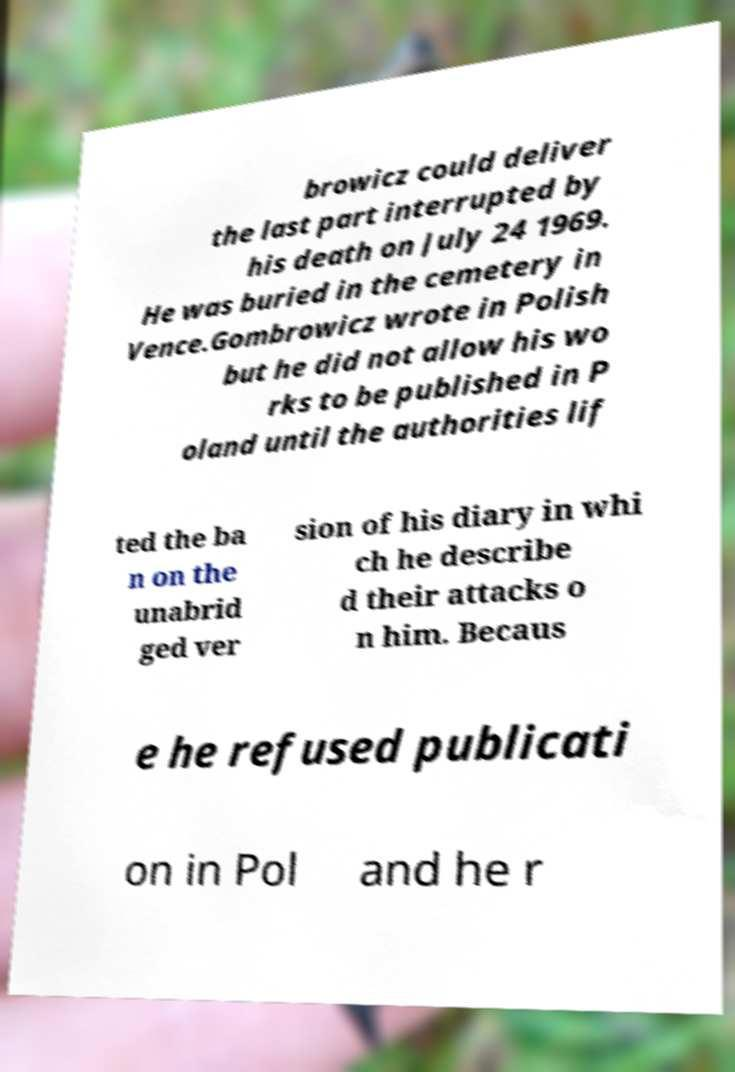Could you extract and type out the text from this image? browicz could deliver the last part interrupted by his death on July 24 1969. He was buried in the cemetery in Vence.Gombrowicz wrote in Polish but he did not allow his wo rks to be published in P oland until the authorities lif ted the ba n on the unabrid ged ver sion of his diary in whi ch he describe d their attacks o n him. Becaus e he refused publicati on in Pol and he r 